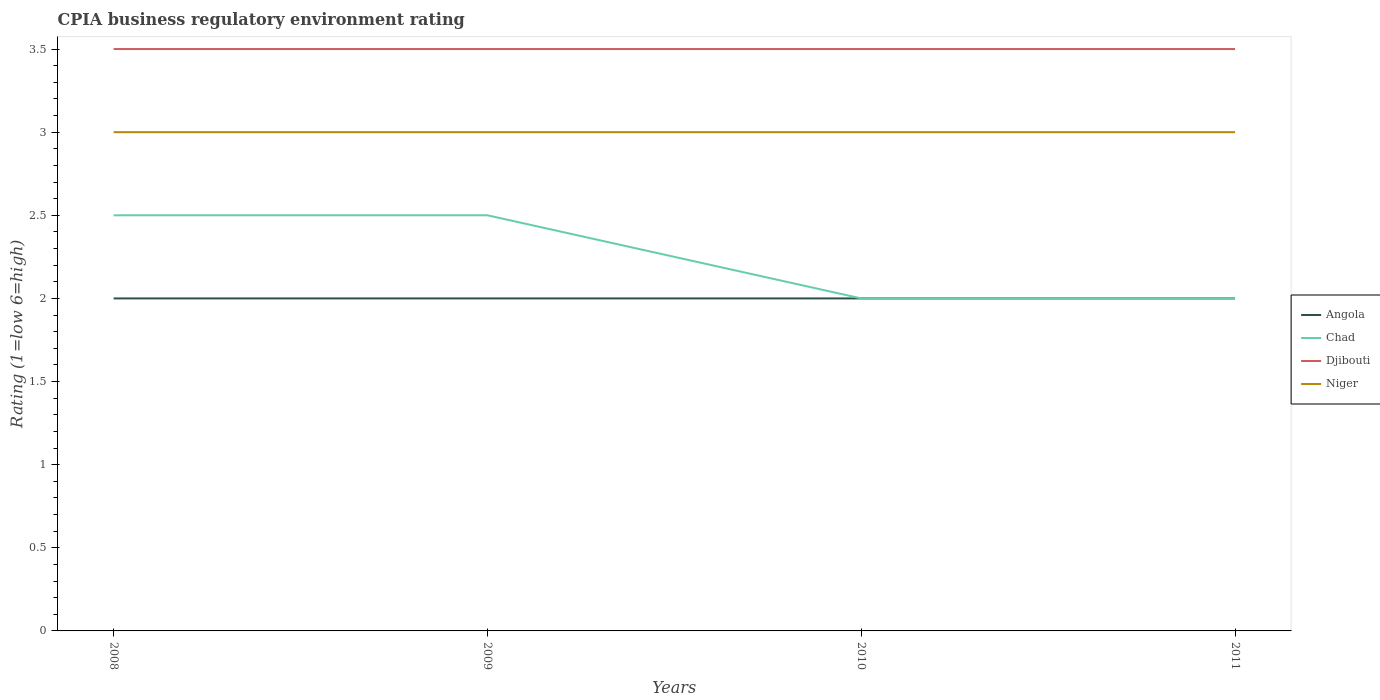How many different coloured lines are there?
Your answer should be compact. 4. Does the line corresponding to Djibouti intersect with the line corresponding to Angola?
Your answer should be very brief. No. Is the number of lines equal to the number of legend labels?
Provide a succinct answer. Yes. In which year was the CPIA rating in Angola maximum?
Provide a short and direct response. 2008. Is the CPIA rating in Angola strictly greater than the CPIA rating in Djibouti over the years?
Make the answer very short. Yes. How many years are there in the graph?
Give a very brief answer. 4. What is the difference between two consecutive major ticks on the Y-axis?
Make the answer very short. 0.5. Does the graph contain any zero values?
Make the answer very short. No. Where does the legend appear in the graph?
Keep it short and to the point. Center right. How many legend labels are there?
Ensure brevity in your answer.  4. How are the legend labels stacked?
Offer a very short reply. Vertical. What is the title of the graph?
Your response must be concise. CPIA business regulatory environment rating. What is the Rating (1=low 6=high) in Djibouti in 2009?
Make the answer very short. 3.5. What is the Rating (1=low 6=high) in Chad in 2010?
Ensure brevity in your answer.  2. What is the Rating (1=low 6=high) of Niger in 2010?
Provide a short and direct response. 3. Across all years, what is the maximum Rating (1=low 6=high) in Angola?
Your answer should be compact. 2. Across all years, what is the minimum Rating (1=low 6=high) in Niger?
Provide a succinct answer. 3. What is the total Rating (1=low 6=high) in Angola in the graph?
Keep it short and to the point. 8. What is the total Rating (1=low 6=high) of Chad in the graph?
Your answer should be very brief. 9. What is the total Rating (1=low 6=high) in Djibouti in the graph?
Your answer should be compact. 14. What is the difference between the Rating (1=low 6=high) in Angola in 2008 and that in 2009?
Your answer should be very brief. 0. What is the difference between the Rating (1=low 6=high) of Chad in 2008 and that in 2009?
Your response must be concise. 0. What is the difference between the Rating (1=low 6=high) of Niger in 2008 and that in 2009?
Make the answer very short. 0. What is the difference between the Rating (1=low 6=high) in Chad in 2008 and that in 2010?
Your response must be concise. 0.5. What is the difference between the Rating (1=low 6=high) in Djibouti in 2008 and that in 2010?
Make the answer very short. 0. What is the difference between the Rating (1=low 6=high) in Angola in 2008 and that in 2011?
Your answer should be very brief. 0. What is the difference between the Rating (1=low 6=high) in Chad in 2008 and that in 2011?
Your answer should be very brief. 0.5. What is the difference between the Rating (1=low 6=high) of Djibouti in 2008 and that in 2011?
Keep it short and to the point. 0. What is the difference between the Rating (1=low 6=high) of Angola in 2009 and that in 2010?
Ensure brevity in your answer.  0. What is the difference between the Rating (1=low 6=high) in Chad in 2009 and that in 2010?
Your response must be concise. 0.5. What is the difference between the Rating (1=low 6=high) in Angola in 2009 and that in 2011?
Offer a terse response. 0. What is the difference between the Rating (1=low 6=high) in Chad in 2009 and that in 2011?
Offer a terse response. 0.5. What is the difference between the Rating (1=low 6=high) in Djibouti in 2009 and that in 2011?
Your answer should be compact. 0. What is the difference between the Rating (1=low 6=high) of Niger in 2009 and that in 2011?
Provide a short and direct response. 0. What is the difference between the Rating (1=low 6=high) in Niger in 2010 and that in 2011?
Your response must be concise. 0. What is the difference between the Rating (1=low 6=high) in Angola in 2008 and the Rating (1=low 6=high) in Chad in 2009?
Give a very brief answer. -0.5. What is the difference between the Rating (1=low 6=high) of Djibouti in 2008 and the Rating (1=low 6=high) of Niger in 2009?
Offer a terse response. 0.5. What is the difference between the Rating (1=low 6=high) of Angola in 2008 and the Rating (1=low 6=high) of Chad in 2010?
Give a very brief answer. 0. What is the difference between the Rating (1=low 6=high) of Angola in 2008 and the Rating (1=low 6=high) of Niger in 2010?
Provide a succinct answer. -1. What is the difference between the Rating (1=low 6=high) of Chad in 2008 and the Rating (1=low 6=high) of Djibouti in 2010?
Provide a short and direct response. -1. What is the difference between the Rating (1=low 6=high) of Djibouti in 2008 and the Rating (1=low 6=high) of Niger in 2010?
Ensure brevity in your answer.  0.5. What is the difference between the Rating (1=low 6=high) of Angola in 2008 and the Rating (1=low 6=high) of Chad in 2011?
Make the answer very short. 0. What is the difference between the Rating (1=low 6=high) in Angola in 2008 and the Rating (1=low 6=high) in Djibouti in 2011?
Give a very brief answer. -1.5. What is the difference between the Rating (1=low 6=high) of Chad in 2008 and the Rating (1=low 6=high) of Djibouti in 2011?
Provide a succinct answer. -1. What is the difference between the Rating (1=low 6=high) of Chad in 2008 and the Rating (1=low 6=high) of Niger in 2011?
Keep it short and to the point. -0.5. What is the difference between the Rating (1=low 6=high) in Angola in 2009 and the Rating (1=low 6=high) in Chad in 2010?
Give a very brief answer. 0. What is the difference between the Rating (1=low 6=high) of Angola in 2009 and the Rating (1=low 6=high) of Djibouti in 2010?
Ensure brevity in your answer.  -1.5. What is the difference between the Rating (1=low 6=high) in Angola in 2009 and the Rating (1=low 6=high) in Chad in 2011?
Make the answer very short. 0. What is the difference between the Rating (1=low 6=high) of Angola in 2009 and the Rating (1=low 6=high) of Djibouti in 2011?
Make the answer very short. -1.5. What is the difference between the Rating (1=low 6=high) of Chad in 2009 and the Rating (1=low 6=high) of Djibouti in 2011?
Give a very brief answer. -1. What is the difference between the Rating (1=low 6=high) in Djibouti in 2009 and the Rating (1=low 6=high) in Niger in 2011?
Offer a terse response. 0.5. What is the difference between the Rating (1=low 6=high) of Angola in 2010 and the Rating (1=low 6=high) of Djibouti in 2011?
Your answer should be compact. -1.5. What is the difference between the Rating (1=low 6=high) in Chad in 2010 and the Rating (1=low 6=high) in Niger in 2011?
Your response must be concise. -1. What is the average Rating (1=low 6=high) of Angola per year?
Your answer should be compact. 2. What is the average Rating (1=low 6=high) in Chad per year?
Make the answer very short. 2.25. In the year 2008, what is the difference between the Rating (1=low 6=high) in Angola and Rating (1=low 6=high) in Niger?
Provide a succinct answer. -1. In the year 2008, what is the difference between the Rating (1=low 6=high) of Chad and Rating (1=low 6=high) of Djibouti?
Give a very brief answer. -1. In the year 2008, what is the difference between the Rating (1=low 6=high) of Djibouti and Rating (1=low 6=high) of Niger?
Give a very brief answer. 0.5. In the year 2009, what is the difference between the Rating (1=low 6=high) of Angola and Rating (1=low 6=high) of Chad?
Offer a terse response. -0.5. In the year 2009, what is the difference between the Rating (1=low 6=high) in Djibouti and Rating (1=low 6=high) in Niger?
Offer a terse response. 0.5. In the year 2010, what is the difference between the Rating (1=low 6=high) of Angola and Rating (1=low 6=high) of Djibouti?
Offer a very short reply. -1.5. In the year 2010, what is the difference between the Rating (1=low 6=high) in Angola and Rating (1=low 6=high) in Niger?
Provide a short and direct response. -1. In the year 2010, what is the difference between the Rating (1=low 6=high) of Djibouti and Rating (1=low 6=high) of Niger?
Ensure brevity in your answer.  0.5. In the year 2011, what is the difference between the Rating (1=low 6=high) in Angola and Rating (1=low 6=high) in Djibouti?
Provide a succinct answer. -1.5. In the year 2011, what is the difference between the Rating (1=low 6=high) of Chad and Rating (1=low 6=high) of Niger?
Your answer should be compact. -1. What is the ratio of the Rating (1=low 6=high) of Angola in 2008 to that in 2009?
Your answer should be compact. 1. What is the ratio of the Rating (1=low 6=high) of Chad in 2008 to that in 2009?
Make the answer very short. 1. What is the ratio of the Rating (1=low 6=high) of Djibouti in 2008 to that in 2009?
Ensure brevity in your answer.  1. What is the ratio of the Rating (1=low 6=high) of Angola in 2008 to that in 2010?
Make the answer very short. 1. What is the ratio of the Rating (1=low 6=high) of Niger in 2008 to that in 2011?
Offer a very short reply. 1. What is the ratio of the Rating (1=low 6=high) of Angola in 2009 to that in 2010?
Provide a short and direct response. 1. What is the ratio of the Rating (1=low 6=high) in Djibouti in 2009 to that in 2010?
Offer a terse response. 1. What is the ratio of the Rating (1=low 6=high) in Niger in 2009 to that in 2010?
Make the answer very short. 1. What is the ratio of the Rating (1=low 6=high) in Niger in 2009 to that in 2011?
Offer a very short reply. 1. What is the ratio of the Rating (1=low 6=high) of Angola in 2010 to that in 2011?
Make the answer very short. 1. What is the ratio of the Rating (1=low 6=high) of Chad in 2010 to that in 2011?
Your response must be concise. 1. What is the ratio of the Rating (1=low 6=high) of Djibouti in 2010 to that in 2011?
Give a very brief answer. 1. What is the ratio of the Rating (1=low 6=high) in Niger in 2010 to that in 2011?
Make the answer very short. 1. What is the difference between the highest and the second highest Rating (1=low 6=high) of Angola?
Your answer should be very brief. 0. What is the difference between the highest and the second highest Rating (1=low 6=high) in Chad?
Offer a very short reply. 0. What is the difference between the highest and the second highest Rating (1=low 6=high) of Niger?
Provide a short and direct response. 0. What is the difference between the highest and the lowest Rating (1=low 6=high) in Angola?
Provide a short and direct response. 0. What is the difference between the highest and the lowest Rating (1=low 6=high) of Chad?
Provide a succinct answer. 0.5. What is the difference between the highest and the lowest Rating (1=low 6=high) in Niger?
Give a very brief answer. 0. 